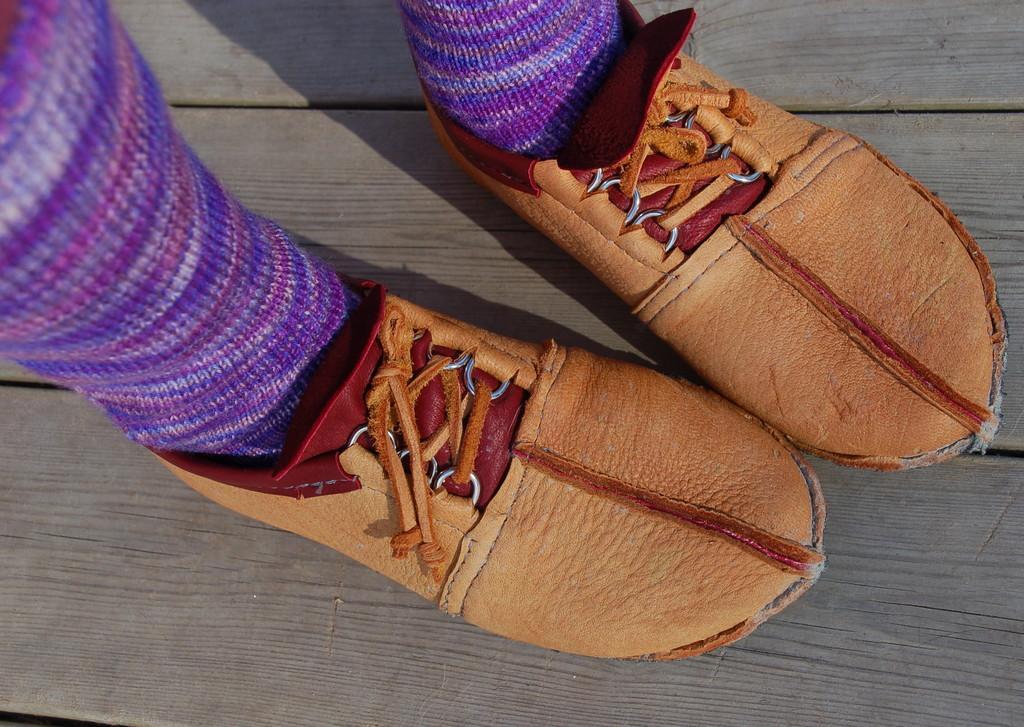Could you give a brief overview of what you see in this image? In this image there is a person standing and wearing a shoes which is brown in colour and sock which is pink in colour. 